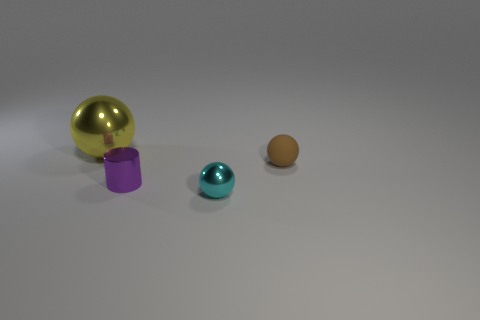Subtract all brown balls. How many balls are left? 2 Subtract all yellow cubes. How many cyan spheres are left? 1 Subtract all tiny balls. How many balls are left? 1 Subtract 1 cylinders. How many cylinders are left? 0 Subtract all red cylinders. Subtract all cyan cubes. How many cylinders are left? 1 Subtract all big rubber cylinders. Subtract all yellow objects. How many objects are left? 3 Add 4 matte spheres. How many matte spheres are left? 5 Add 4 tiny purple cylinders. How many tiny purple cylinders exist? 5 Add 3 tiny purple cylinders. How many objects exist? 7 Subtract 0 gray blocks. How many objects are left? 4 